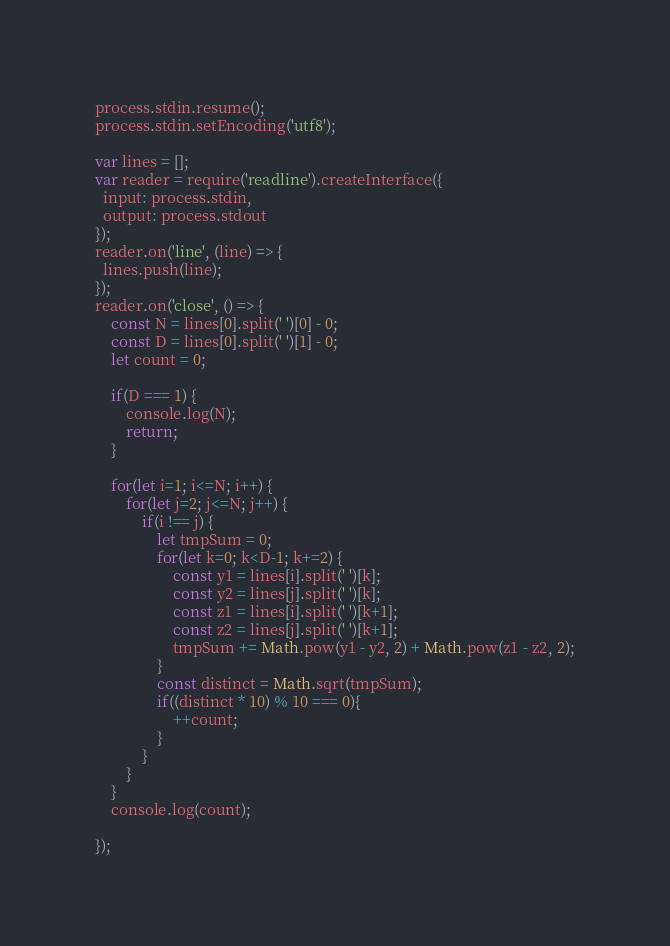Convert code to text. <code><loc_0><loc_0><loc_500><loc_500><_JavaScript_>process.stdin.resume();
process.stdin.setEncoding('utf8');

var lines = [];
var reader = require('readline').createInterface({
  input: process.stdin,
  output: process.stdout
});
reader.on('line', (line) => {
  lines.push(line);
});
reader.on('close', () => {
    const N = lines[0].split(' ')[0] - 0;
    const D = lines[0].split(' ')[1] - 0;
    let count = 0;
    
    if(D === 1) {
        console.log(N);
        return;
    }
    
    for(let i=1; i<=N; i++) {
        for(let j=2; j<=N; j++) {
            if(i !== j) {
                let tmpSum = 0;
                for(let k=0; k<D-1; k+=2) {
                    const y1 = lines[i].split(' ')[k];
                    const y2 = lines[j].split(' ')[k];
                    const z1 = lines[i].split(' ')[k+1];
                    const z2 = lines[j].split(' ')[k+1];
                    tmpSum += Math.pow(y1 - y2, 2) + Math.pow(z1 - z2, 2);
                }
                const distinct = Math.sqrt(tmpSum);
                if((distinct * 10) % 10 === 0){
                    ++count;   
                }
            }
        }
    }
    console.log(count);
    
});</code> 